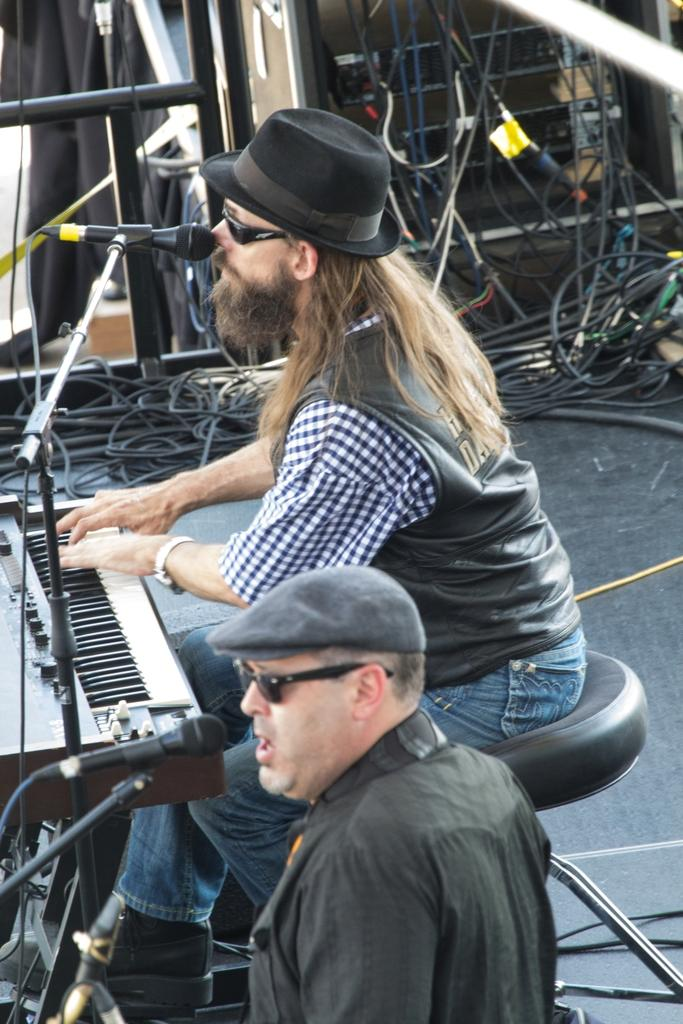How many people are in the image? There are two men in the image. What are the men doing in the image? The men are in front of microphones. What instrument is present in the image? There is a piano in front of one of the men. What can be seen in the background of the image? There is equipment visible in the background, along with multiple wires. What type of kettle is visible on the piano in the image? There is no kettle present on the piano in the image. Can you describe the marble floor in the image? There is no marble floor visible in the image. 